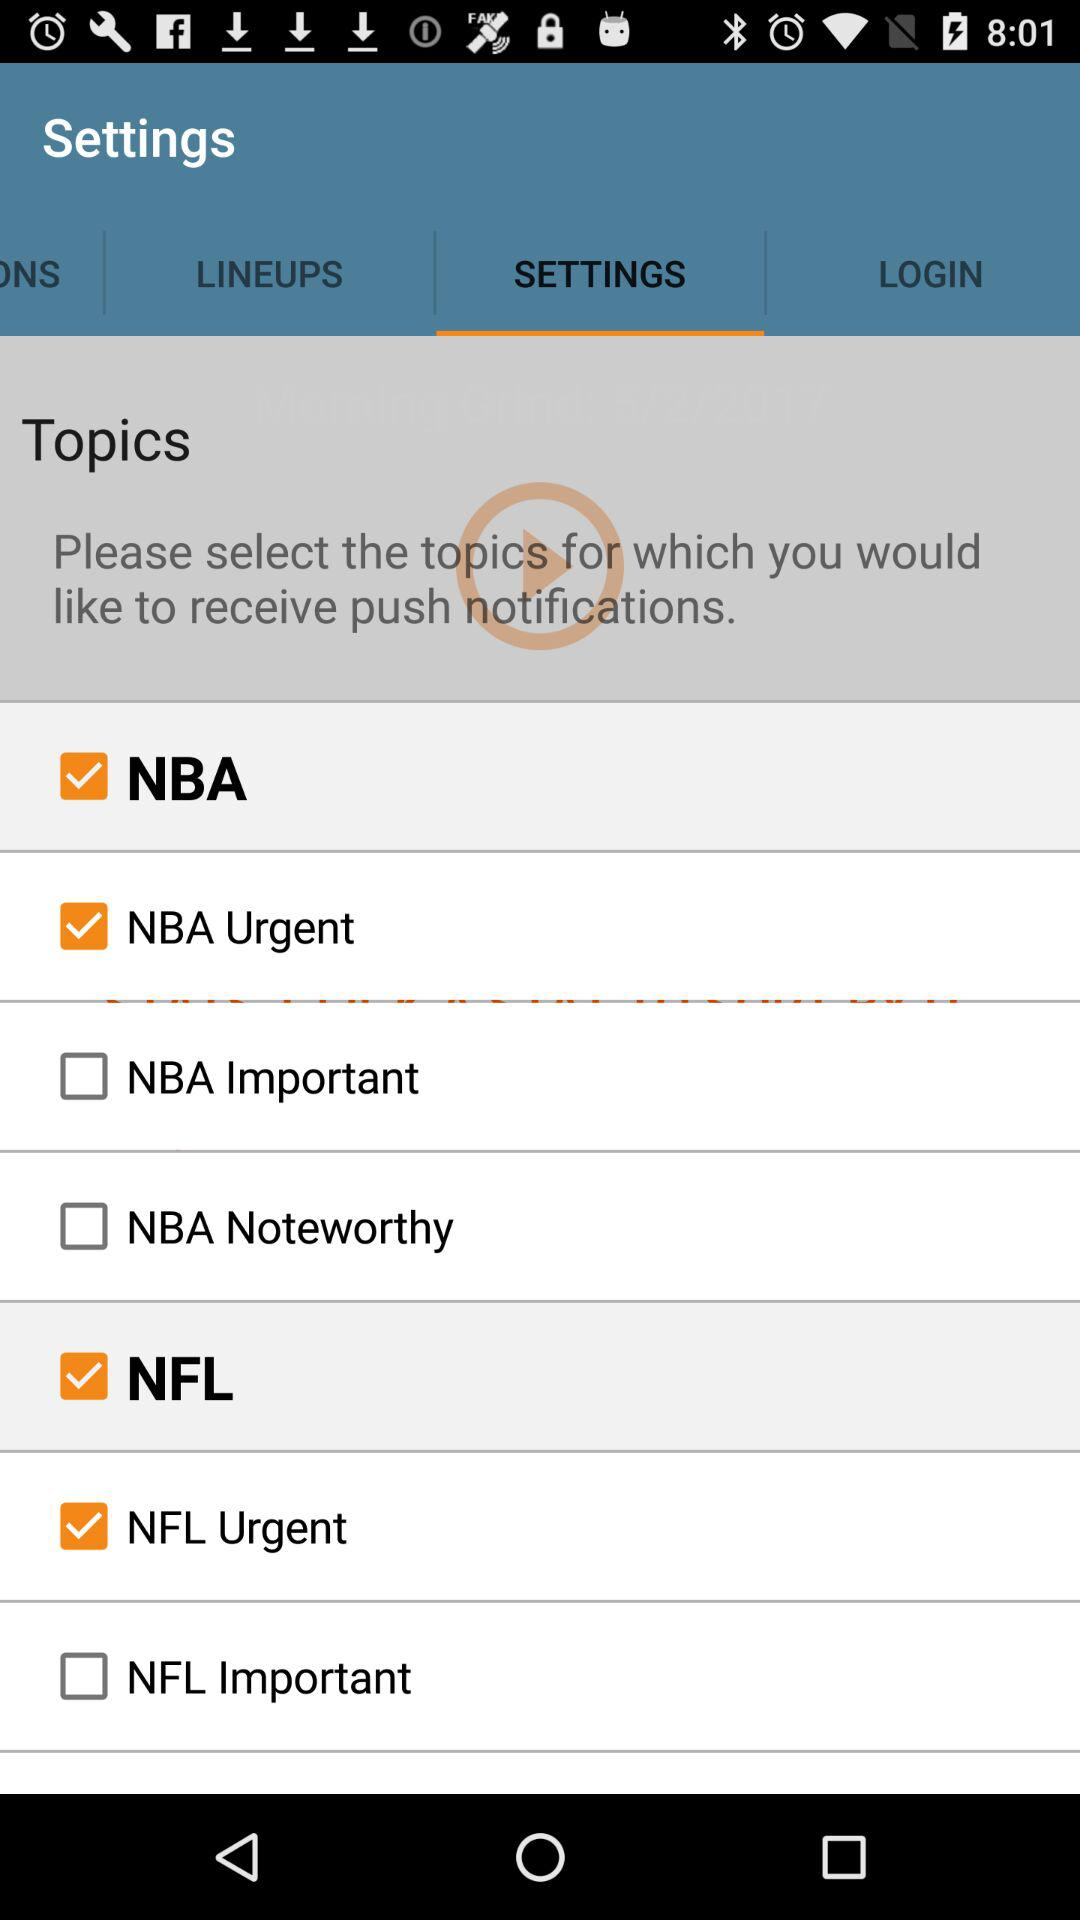How many categories are available in the NFL?
When the provided information is insufficient, respond with <no answer>. <no answer> 